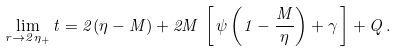<formula> <loc_0><loc_0><loc_500><loc_500>\lim _ { r \rightarrow 2 \eta _ { + } } t = 2 ( \eta - M ) + 2 M \, \left [ \, \psi \left ( 1 - \frac { M } { \eta } \right ) + \gamma \, \right ] + Q \, .</formula> 